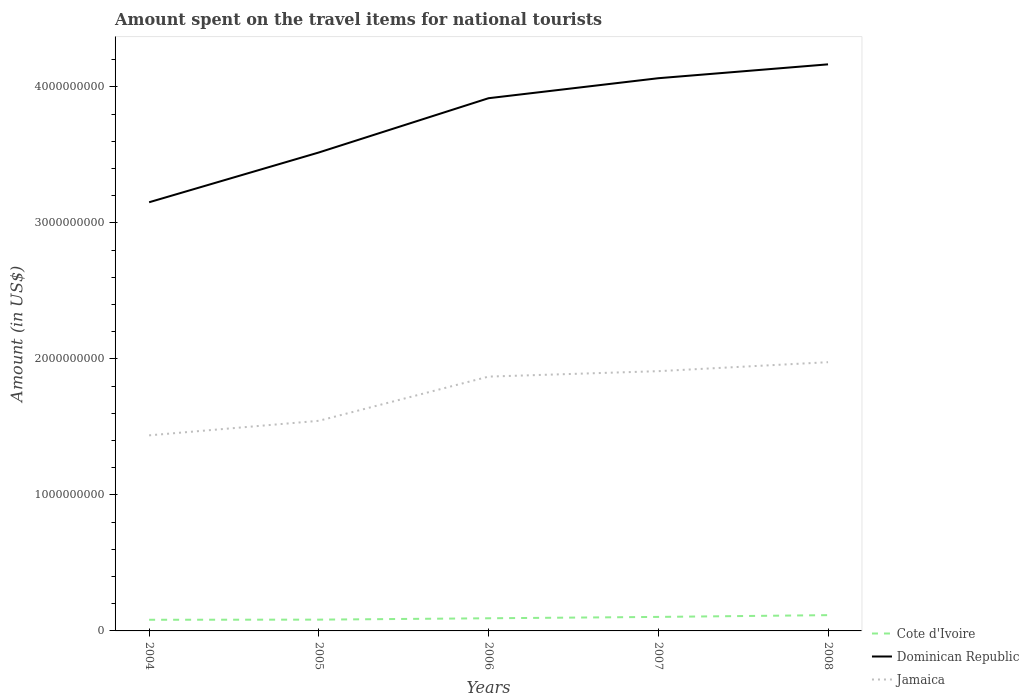Across all years, what is the maximum amount spent on the travel items for national tourists in Jamaica?
Provide a succinct answer. 1.44e+09. In which year was the amount spent on the travel items for national tourists in Dominican Republic maximum?
Give a very brief answer. 2004. What is the total amount spent on the travel items for national tourists in Dominican Republic in the graph?
Offer a terse response. -1.47e+08. What is the difference between the highest and the second highest amount spent on the travel items for national tourists in Dominican Republic?
Your response must be concise. 1.01e+09. Is the amount spent on the travel items for national tourists in Jamaica strictly greater than the amount spent on the travel items for national tourists in Cote d'Ivoire over the years?
Give a very brief answer. No. How many years are there in the graph?
Offer a terse response. 5. Does the graph contain any zero values?
Provide a short and direct response. No. Where does the legend appear in the graph?
Ensure brevity in your answer.  Bottom right. What is the title of the graph?
Give a very brief answer. Amount spent on the travel items for national tourists. Does "Puerto Rico" appear as one of the legend labels in the graph?
Provide a short and direct response. No. What is the label or title of the Y-axis?
Your response must be concise. Amount (in US$). What is the Amount (in US$) of Cote d'Ivoire in 2004?
Provide a succinct answer. 8.20e+07. What is the Amount (in US$) in Dominican Republic in 2004?
Keep it short and to the point. 3.15e+09. What is the Amount (in US$) in Jamaica in 2004?
Your answer should be very brief. 1.44e+09. What is the Amount (in US$) in Cote d'Ivoire in 2005?
Offer a very short reply. 8.30e+07. What is the Amount (in US$) of Dominican Republic in 2005?
Your response must be concise. 3.52e+09. What is the Amount (in US$) of Jamaica in 2005?
Keep it short and to the point. 1.54e+09. What is the Amount (in US$) of Cote d'Ivoire in 2006?
Provide a succinct answer. 9.30e+07. What is the Amount (in US$) of Dominican Republic in 2006?
Your answer should be compact. 3.92e+09. What is the Amount (in US$) of Jamaica in 2006?
Provide a succinct answer. 1.87e+09. What is the Amount (in US$) in Cote d'Ivoire in 2007?
Give a very brief answer. 1.03e+08. What is the Amount (in US$) in Dominican Republic in 2007?
Your answer should be very brief. 4.06e+09. What is the Amount (in US$) in Jamaica in 2007?
Ensure brevity in your answer.  1.91e+09. What is the Amount (in US$) in Cote d'Ivoire in 2008?
Provide a short and direct response. 1.16e+08. What is the Amount (in US$) of Dominican Republic in 2008?
Make the answer very short. 4.17e+09. What is the Amount (in US$) in Jamaica in 2008?
Your response must be concise. 1.98e+09. Across all years, what is the maximum Amount (in US$) of Cote d'Ivoire?
Make the answer very short. 1.16e+08. Across all years, what is the maximum Amount (in US$) of Dominican Republic?
Your answer should be compact. 4.17e+09. Across all years, what is the maximum Amount (in US$) in Jamaica?
Offer a terse response. 1.98e+09. Across all years, what is the minimum Amount (in US$) in Cote d'Ivoire?
Your response must be concise. 8.20e+07. Across all years, what is the minimum Amount (in US$) in Dominican Republic?
Give a very brief answer. 3.15e+09. Across all years, what is the minimum Amount (in US$) of Jamaica?
Keep it short and to the point. 1.44e+09. What is the total Amount (in US$) in Cote d'Ivoire in the graph?
Make the answer very short. 4.77e+08. What is the total Amount (in US$) of Dominican Republic in the graph?
Offer a terse response. 1.88e+1. What is the total Amount (in US$) of Jamaica in the graph?
Offer a very short reply. 8.74e+09. What is the difference between the Amount (in US$) of Cote d'Ivoire in 2004 and that in 2005?
Make the answer very short. -1.00e+06. What is the difference between the Amount (in US$) of Dominican Republic in 2004 and that in 2005?
Make the answer very short. -3.66e+08. What is the difference between the Amount (in US$) in Jamaica in 2004 and that in 2005?
Give a very brief answer. -1.07e+08. What is the difference between the Amount (in US$) of Cote d'Ivoire in 2004 and that in 2006?
Your response must be concise. -1.10e+07. What is the difference between the Amount (in US$) of Dominican Republic in 2004 and that in 2006?
Make the answer very short. -7.65e+08. What is the difference between the Amount (in US$) of Jamaica in 2004 and that in 2006?
Ensure brevity in your answer.  -4.32e+08. What is the difference between the Amount (in US$) in Cote d'Ivoire in 2004 and that in 2007?
Offer a terse response. -2.10e+07. What is the difference between the Amount (in US$) of Dominican Republic in 2004 and that in 2007?
Make the answer very short. -9.12e+08. What is the difference between the Amount (in US$) of Jamaica in 2004 and that in 2007?
Offer a terse response. -4.72e+08. What is the difference between the Amount (in US$) of Cote d'Ivoire in 2004 and that in 2008?
Offer a terse response. -3.40e+07. What is the difference between the Amount (in US$) of Dominican Republic in 2004 and that in 2008?
Offer a terse response. -1.01e+09. What is the difference between the Amount (in US$) of Jamaica in 2004 and that in 2008?
Your answer should be very brief. -5.38e+08. What is the difference between the Amount (in US$) in Cote d'Ivoire in 2005 and that in 2006?
Give a very brief answer. -1.00e+07. What is the difference between the Amount (in US$) in Dominican Republic in 2005 and that in 2006?
Your answer should be compact. -3.99e+08. What is the difference between the Amount (in US$) in Jamaica in 2005 and that in 2006?
Provide a short and direct response. -3.25e+08. What is the difference between the Amount (in US$) in Cote d'Ivoire in 2005 and that in 2007?
Keep it short and to the point. -2.00e+07. What is the difference between the Amount (in US$) of Dominican Republic in 2005 and that in 2007?
Provide a short and direct response. -5.46e+08. What is the difference between the Amount (in US$) in Jamaica in 2005 and that in 2007?
Provide a short and direct response. -3.65e+08. What is the difference between the Amount (in US$) of Cote d'Ivoire in 2005 and that in 2008?
Offer a terse response. -3.30e+07. What is the difference between the Amount (in US$) in Dominican Republic in 2005 and that in 2008?
Keep it short and to the point. -6.48e+08. What is the difference between the Amount (in US$) of Jamaica in 2005 and that in 2008?
Your answer should be very brief. -4.31e+08. What is the difference between the Amount (in US$) of Cote d'Ivoire in 2006 and that in 2007?
Provide a succinct answer. -1.00e+07. What is the difference between the Amount (in US$) of Dominican Republic in 2006 and that in 2007?
Your answer should be very brief. -1.47e+08. What is the difference between the Amount (in US$) in Jamaica in 2006 and that in 2007?
Offer a very short reply. -4.00e+07. What is the difference between the Amount (in US$) of Cote d'Ivoire in 2006 and that in 2008?
Provide a short and direct response. -2.30e+07. What is the difference between the Amount (in US$) of Dominican Republic in 2006 and that in 2008?
Offer a terse response. -2.49e+08. What is the difference between the Amount (in US$) in Jamaica in 2006 and that in 2008?
Make the answer very short. -1.06e+08. What is the difference between the Amount (in US$) in Cote d'Ivoire in 2007 and that in 2008?
Your answer should be very brief. -1.30e+07. What is the difference between the Amount (in US$) of Dominican Republic in 2007 and that in 2008?
Give a very brief answer. -1.02e+08. What is the difference between the Amount (in US$) in Jamaica in 2007 and that in 2008?
Keep it short and to the point. -6.60e+07. What is the difference between the Amount (in US$) in Cote d'Ivoire in 2004 and the Amount (in US$) in Dominican Republic in 2005?
Provide a short and direct response. -3.44e+09. What is the difference between the Amount (in US$) of Cote d'Ivoire in 2004 and the Amount (in US$) of Jamaica in 2005?
Offer a terse response. -1.46e+09. What is the difference between the Amount (in US$) of Dominican Republic in 2004 and the Amount (in US$) of Jamaica in 2005?
Offer a very short reply. 1.61e+09. What is the difference between the Amount (in US$) in Cote d'Ivoire in 2004 and the Amount (in US$) in Dominican Republic in 2006?
Provide a short and direct response. -3.84e+09. What is the difference between the Amount (in US$) of Cote d'Ivoire in 2004 and the Amount (in US$) of Jamaica in 2006?
Your response must be concise. -1.79e+09. What is the difference between the Amount (in US$) in Dominican Republic in 2004 and the Amount (in US$) in Jamaica in 2006?
Give a very brief answer. 1.28e+09. What is the difference between the Amount (in US$) in Cote d'Ivoire in 2004 and the Amount (in US$) in Dominican Republic in 2007?
Make the answer very short. -3.98e+09. What is the difference between the Amount (in US$) in Cote d'Ivoire in 2004 and the Amount (in US$) in Jamaica in 2007?
Your response must be concise. -1.83e+09. What is the difference between the Amount (in US$) in Dominican Republic in 2004 and the Amount (in US$) in Jamaica in 2007?
Your response must be concise. 1.24e+09. What is the difference between the Amount (in US$) in Cote d'Ivoire in 2004 and the Amount (in US$) in Dominican Republic in 2008?
Offer a terse response. -4.08e+09. What is the difference between the Amount (in US$) of Cote d'Ivoire in 2004 and the Amount (in US$) of Jamaica in 2008?
Give a very brief answer. -1.89e+09. What is the difference between the Amount (in US$) of Dominican Republic in 2004 and the Amount (in US$) of Jamaica in 2008?
Provide a short and direct response. 1.18e+09. What is the difference between the Amount (in US$) in Cote d'Ivoire in 2005 and the Amount (in US$) in Dominican Republic in 2006?
Give a very brief answer. -3.83e+09. What is the difference between the Amount (in US$) in Cote d'Ivoire in 2005 and the Amount (in US$) in Jamaica in 2006?
Your response must be concise. -1.79e+09. What is the difference between the Amount (in US$) in Dominican Republic in 2005 and the Amount (in US$) in Jamaica in 2006?
Provide a short and direct response. 1.65e+09. What is the difference between the Amount (in US$) of Cote d'Ivoire in 2005 and the Amount (in US$) of Dominican Republic in 2007?
Keep it short and to the point. -3.98e+09. What is the difference between the Amount (in US$) in Cote d'Ivoire in 2005 and the Amount (in US$) in Jamaica in 2007?
Give a very brief answer. -1.83e+09. What is the difference between the Amount (in US$) of Dominican Republic in 2005 and the Amount (in US$) of Jamaica in 2007?
Keep it short and to the point. 1.61e+09. What is the difference between the Amount (in US$) in Cote d'Ivoire in 2005 and the Amount (in US$) in Dominican Republic in 2008?
Ensure brevity in your answer.  -4.08e+09. What is the difference between the Amount (in US$) in Cote d'Ivoire in 2005 and the Amount (in US$) in Jamaica in 2008?
Provide a succinct answer. -1.89e+09. What is the difference between the Amount (in US$) of Dominican Republic in 2005 and the Amount (in US$) of Jamaica in 2008?
Ensure brevity in your answer.  1.54e+09. What is the difference between the Amount (in US$) in Cote d'Ivoire in 2006 and the Amount (in US$) in Dominican Republic in 2007?
Keep it short and to the point. -3.97e+09. What is the difference between the Amount (in US$) of Cote d'Ivoire in 2006 and the Amount (in US$) of Jamaica in 2007?
Give a very brief answer. -1.82e+09. What is the difference between the Amount (in US$) of Dominican Republic in 2006 and the Amount (in US$) of Jamaica in 2007?
Your answer should be very brief. 2.01e+09. What is the difference between the Amount (in US$) in Cote d'Ivoire in 2006 and the Amount (in US$) in Dominican Republic in 2008?
Your answer should be very brief. -4.07e+09. What is the difference between the Amount (in US$) in Cote d'Ivoire in 2006 and the Amount (in US$) in Jamaica in 2008?
Make the answer very short. -1.88e+09. What is the difference between the Amount (in US$) of Dominican Republic in 2006 and the Amount (in US$) of Jamaica in 2008?
Offer a terse response. 1.94e+09. What is the difference between the Amount (in US$) in Cote d'Ivoire in 2007 and the Amount (in US$) in Dominican Republic in 2008?
Offer a terse response. -4.06e+09. What is the difference between the Amount (in US$) in Cote d'Ivoire in 2007 and the Amount (in US$) in Jamaica in 2008?
Provide a succinct answer. -1.87e+09. What is the difference between the Amount (in US$) of Dominican Republic in 2007 and the Amount (in US$) of Jamaica in 2008?
Your answer should be compact. 2.09e+09. What is the average Amount (in US$) in Cote d'Ivoire per year?
Keep it short and to the point. 9.54e+07. What is the average Amount (in US$) of Dominican Republic per year?
Provide a short and direct response. 3.76e+09. What is the average Amount (in US$) in Jamaica per year?
Offer a very short reply. 1.75e+09. In the year 2004, what is the difference between the Amount (in US$) of Cote d'Ivoire and Amount (in US$) of Dominican Republic?
Your response must be concise. -3.07e+09. In the year 2004, what is the difference between the Amount (in US$) of Cote d'Ivoire and Amount (in US$) of Jamaica?
Your answer should be compact. -1.36e+09. In the year 2004, what is the difference between the Amount (in US$) in Dominican Republic and Amount (in US$) in Jamaica?
Ensure brevity in your answer.  1.71e+09. In the year 2005, what is the difference between the Amount (in US$) in Cote d'Ivoire and Amount (in US$) in Dominican Republic?
Offer a terse response. -3.44e+09. In the year 2005, what is the difference between the Amount (in US$) of Cote d'Ivoire and Amount (in US$) of Jamaica?
Offer a very short reply. -1.46e+09. In the year 2005, what is the difference between the Amount (in US$) of Dominican Republic and Amount (in US$) of Jamaica?
Ensure brevity in your answer.  1.97e+09. In the year 2006, what is the difference between the Amount (in US$) of Cote d'Ivoire and Amount (in US$) of Dominican Republic?
Make the answer very short. -3.82e+09. In the year 2006, what is the difference between the Amount (in US$) of Cote d'Ivoire and Amount (in US$) of Jamaica?
Make the answer very short. -1.78e+09. In the year 2006, what is the difference between the Amount (in US$) in Dominican Republic and Amount (in US$) in Jamaica?
Your answer should be very brief. 2.05e+09. In the year 2007, what is the difference between the Amount (in US$) in Cote d'Ivoire and Amount (in US$) in Dominican Republic?
Your answer should be compact. -3.96e+09. In the year 2007, what is the difference between the Amount (in US$) in Cote d'Ivoire and Amount (in US$) in Jamaica?
Ensure brevity in your answer.  -1.81e+09. In the year 2007, what is the difference between the Amount (in US$) of Dominican Republic and Amount (in US$) of Jamaica?
Offer a terse response. 2.15e+09. In the year 2008, what is the difference between the Amount (in US$) in Cote d'Ivoire and Amount (in US$) in Dominican Republic?
Your response must be concise. -4.05e+09. In the year 2008, what is the difference between the Amount (in US$) of Cote d'Ivoire and Amount (in US$) of Jamaica?
Offer a terse response. -1.86e+09. In the year 2008, what is the difference between the Amount (in US$) of Dominican Republic and Amount (in US$) of Jamaica?
Your answer should be very brief. 2.19e+09. What is the ratio of the Amount (in US$) of Dominican Republic in 2004 to that in 2005?
Your answer should be very brief. 0.9. What is the ratio of the Amount (in US$) in Jamaica in 2004 to that in 2005?
Provide a short and direct response. 0.93. What is the ratio of the Amount (in US$) in Cote d'Ivoire in 2004 to that in 2006?
Make the answer very short. 0.88. What is the ratio of the Amount (in US$) in Dominican Republic in 2004 to that in 2006?
Your answer should be compact. 0.8. What is the ratio of the Amount (in US$) in Jamaica in 2004 to that in 2006?
Keep it short and to the point. 0.77. What is the ratio of the Amount (in US$) of Cote d'Ivoire in 2004 to that in 2007?
Your answer should be very brief. 0.8. What is the ratio of the Amount (in US$) of Dominican Republic in 2004 to that in 2007?
Provide a short and direct response. 0.78. What is the ratio of the Amount (in US$) of Jamaica in 2004 to that in 2007?
Your response must be concise. 0.75. What is the ratio of the Amount (in US$) in Cote d'Ivoire in 2004 to that in 2008?
Provide a succinct answer. 0.71. What is the ratio of the Amount (in US$) of Dominican Republic in 2004 to that in 2008?
Provide a succinct answer. 0.76. What is the ratio of the Amount (in US$) in Jamaica in 2004 to that in 2008?
Offer a terse response. 0.73. What is the ratio of the Amount (in US$) of Cote d'Ivoire in 2005 to that in 2006?
Your response must be concise. 0.89. What is the ratio of the Amount (in US$) in Dominican Republic in 2005 to that in 2006?
Your answer should be very brief. 0.9. What is the ratio of the Amount (in US$) of Jamaica in 2005 to that in 2006?
Your response must be concise. 0.83. What is the ratio of the Amount (in US$) of Cote d'Ivoire in 2005 to that in 2007?
Your answer should be compact. 0.81. What is the ratio of the Amount (in US$) of Dominican Republic in 2005 to that in 2007?
Keep it short and to the point. 0.87. What is the ratio of the Amount (in US$) of Jamaica in 2005 to that in 2007?
Your answer should be very brief. 0.81. What is the ratio of the Amount (in US$) in Cote d'Ivoire in 2005 to that in 2008?
Keep it short and to the point. 0.72. What is the ratio of the Amount (in US$) of Dominican Republic in 2005 to that in 2008?
Give a very brief answer. 0.84. What is the ratio of the Amount (in US$) of Jamaica in 2005 to that in 2008?
Give a very brief answer. 0.78. What is the ratio of the Amount (in US$) of Cote d'Ivoire in 2006 to that in 2007?
Provide a short and direct response. 0.9. What is the ratio of the Amount (in US$) in Dominican Republic in 2006 to that in 2007?
Offer a terse response. 0.96. What is the ratio of the Amount (in US$) in Jamaica in 2006 to that in 2007?
Give a very brief answer. 0.98. What is the ratio of the Amount (in US$) of Cote d'Ivoire in 2006 to that in 2008?
Offer a very short reply. 0.8. What is the ratio of the Amount (in US$) of Dominican Republic in 2006 to that in 2008?
Your answer should be compact. 0.94. What is the ratio of the Amount (in US$) of Jamaica in 2006 to that in 2008?
Provide a short and direct response. 0.95. What is the ratio of the Amount (in US$) in Cote d'Ivoire in 2007 to that in 2008?
Your response must be concise. 0.89. What is the ratio of the Amount (in US$) in Dominican Republic in 2007 to that in 2008?
Provide a succinct answer. 0.98. What is the ratio of the Amount (in US$) in Jamaica in 2007 to that in 2008?
Offer a terse response. 0.97. What is the difference between the highest and the second highest Amount (in US$) of Cote d'Ivoire?
Your response must be concise. 1.30e+07. What is the difference between the highest and the second highest Amount (in US$) of Dominican Republic?
Provide a short and direct response. 1.02e+08. What is the difference between the highest and the second highest Amount (in US$) of Jamaica?
Give a very brief answer. 6.60e+07. What is the difference between the highest and the lowest Amount (in US$) in Cote d'Ivoire?
Provide a short and direct response. 3.40e+07. What is the difference between the highest and the lowest Amount (in US$) in Dominican Republic?
Your answer should be compact. 1.01e+09. What is the difference between the highest and the lowest Amount (in US$) of Jamaica?
Give a very brief answer. 5.38e+08. 